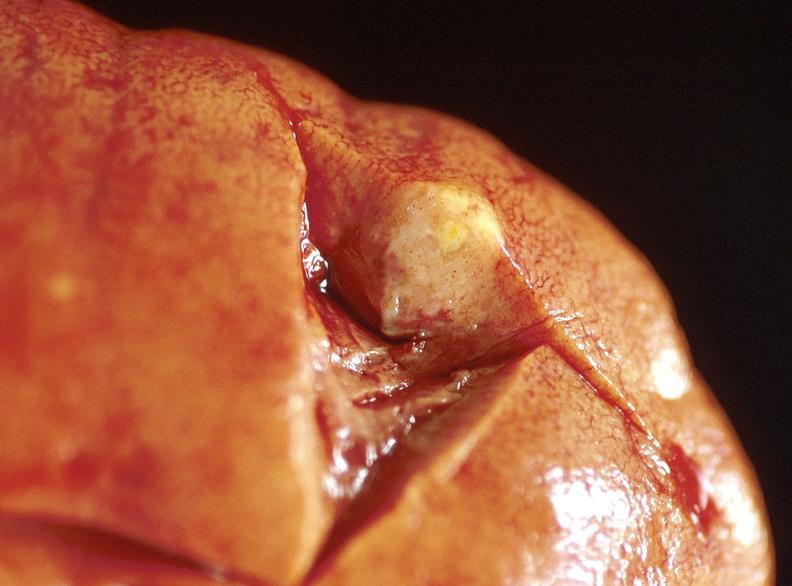where is this?
Answer the question using a single word or phrase. Urinary 